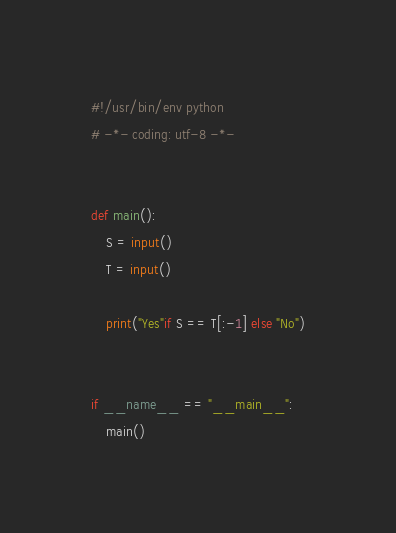<code> <loc_0><loc_0><loc_500><loc_500><_Python_>#!/usr/bin/env python
# -*- coding: utf-8 -*-


def main():
    S = input()
    T = input()

    print("Yes"if S == T[:-1] else "No")


if __name__ == "__main__":
    main()
</code> 